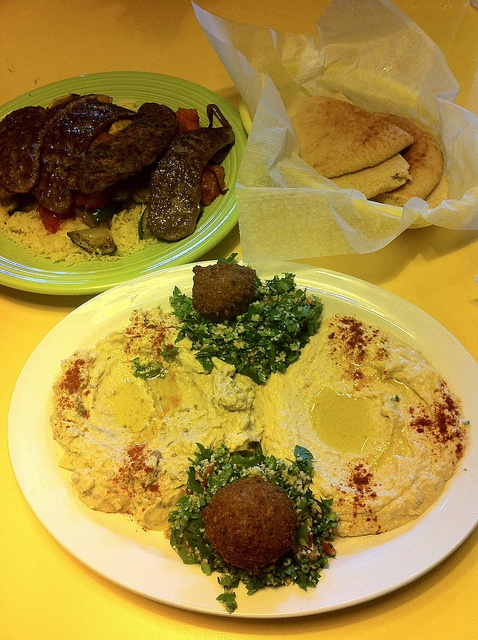Describe the objects in this image and their specific colors. I can see a bowl in olive, tan, and darkgray tones in this image. 